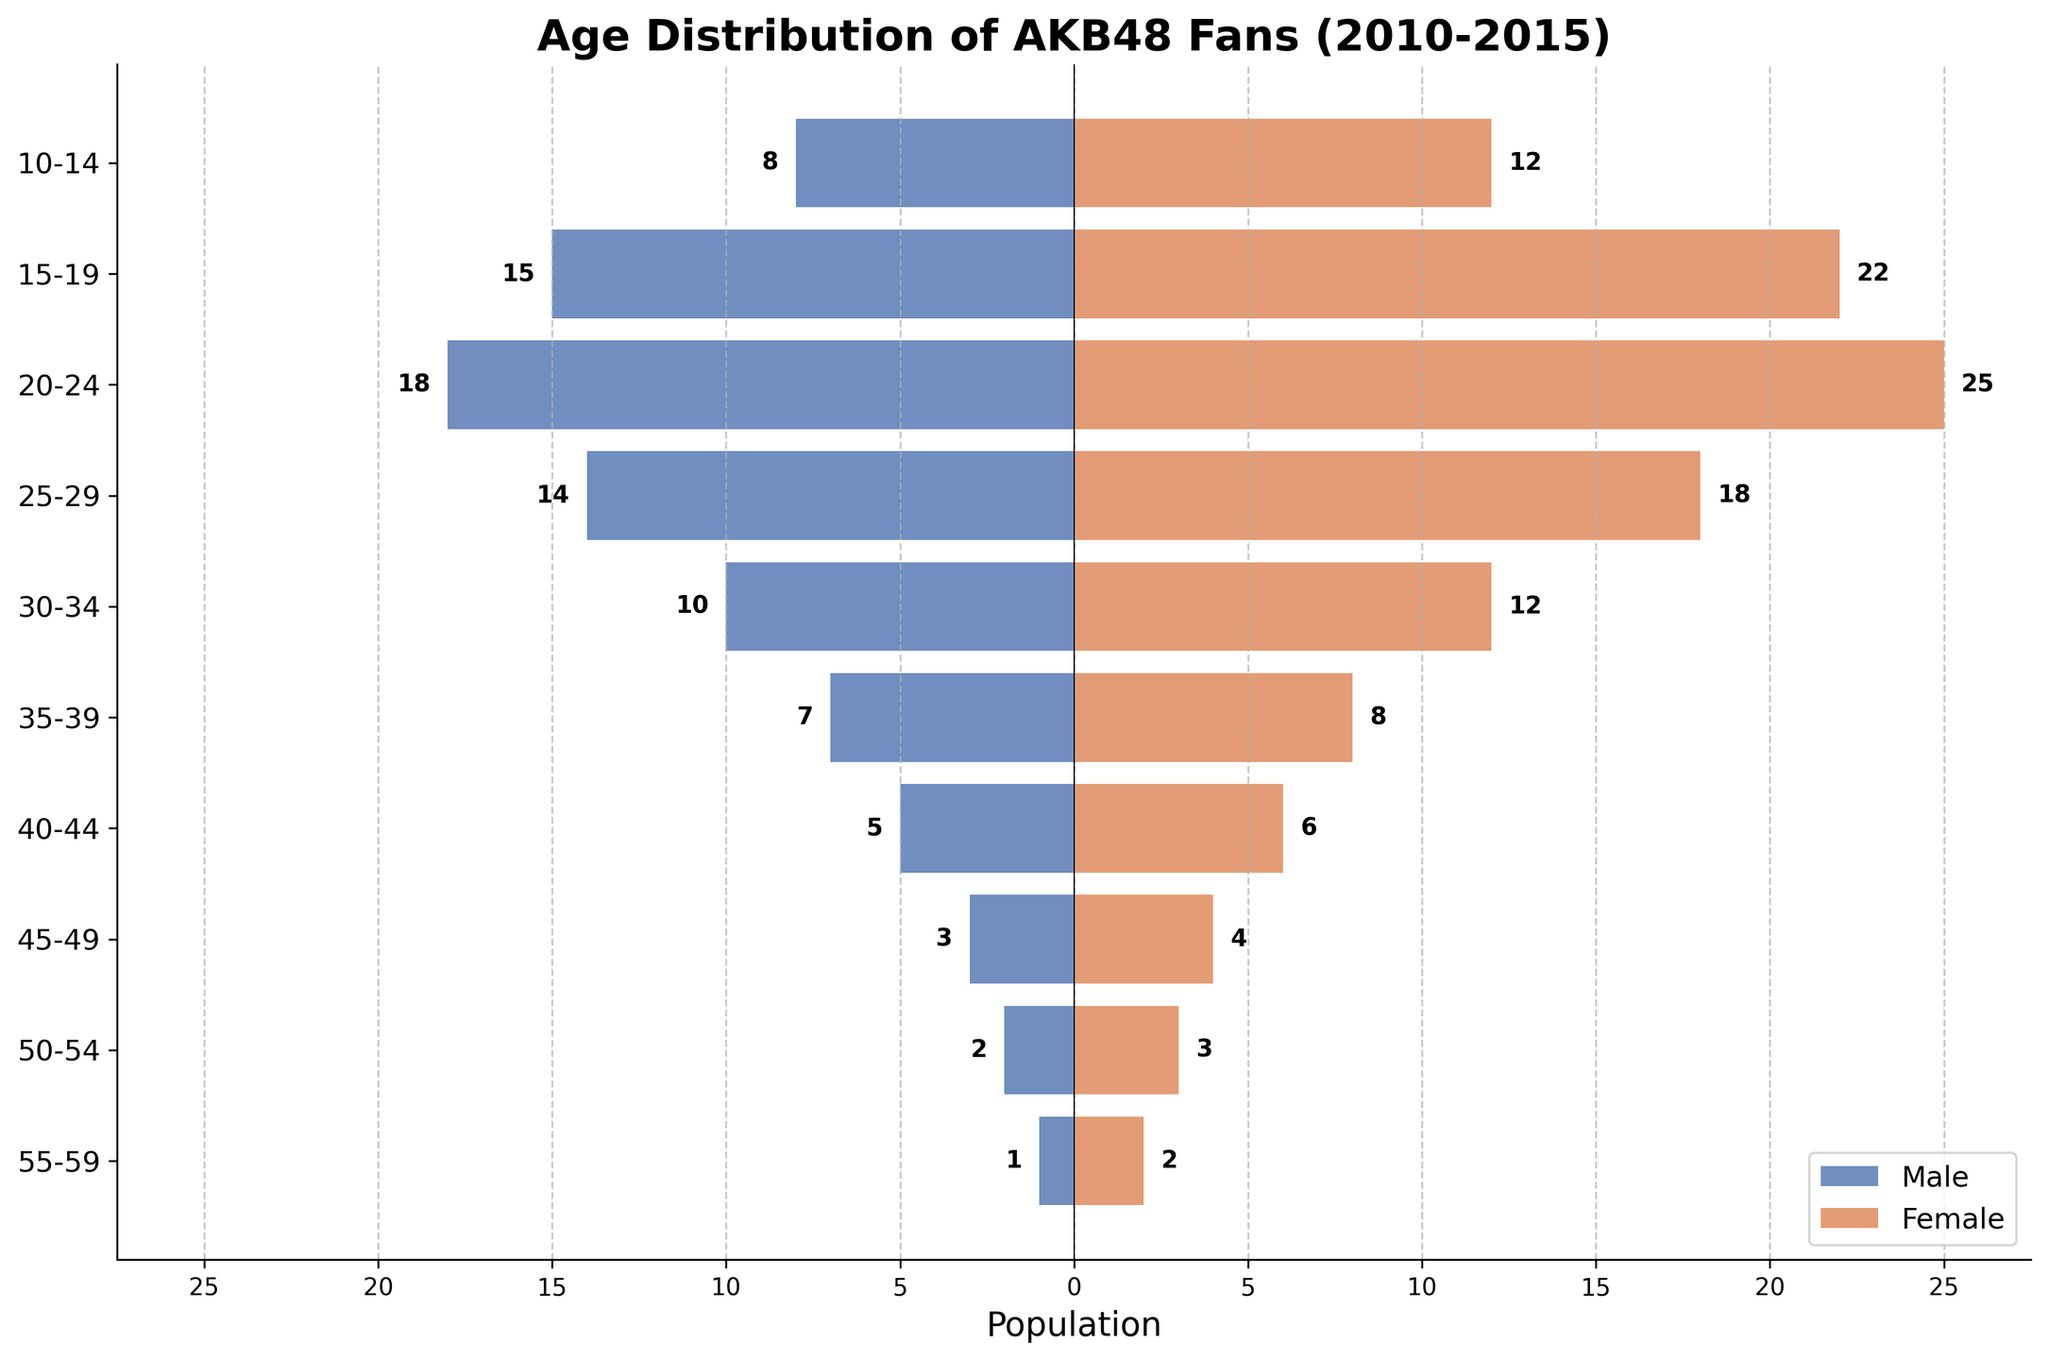How many age groups are there in the figure? Count all the unique age groups listed on the y-axis labels. There are 10 age groups: "10-14", "15-19", "20-24", "25-29", "30-34", "35-39", "40-44", "45-49", "50-54", and "55-59".
Answer: 10 What is the title of the figure? The title is displayed at the top of the figure. It reads "Age Distribution of AKB48 Fans (2010-2015)".
Answer: Age Distribution of AKB48 Fans (2010-2015) Which age group has the highest number of female fans? Look at the bar lengths for all age groups and focus on the female (right) side. The longest bar is for the "20-24" age group with 25 female fans.
Answer: 20-24 What is the total number of male fans? Sum the absolute values of all bars representing male fans: 8 + 15 + 18 + 14 + 10 + 7 + 5 + 3 + 2 + 1 = 83.
Answer: 83 What is the difference in the number of fans between males and females in the "15-19" age group? Look at the bar lengths for the "15-19" age group. There are 15 male fans and 22 female fans. The difference is 22 - 15 = 7.
Answer: 7 Which gender has more fans in the "35-39" age group? Compare the bar lengths for the "35-39" age group. There are 7 male fans and 8 female fans. Females have more fans.
Answer: Females What is the average number of female fans across all age groups? Sum the number of female fans across all age groups and divide by the number of age groups. (12 + 22 + 25 + 18 + 12 + 8 + 6 + 4 + 3 + 2) / 10 = 112 / 10 = 11.2
Answer: 11.2 Which age group has the lowest total number of fans (males + females)? Calculate the total number of fans for each age group and find the smallest: (10-14: 8+12=20), (15-19: 15+22=37), (20-24: 18+25=43), (25-29: 14+18=32), (30-34: 10+12=22), (35-39: 7+8=15), (40-44: 5+6=11), (45-49: 3+4=7), (50-54: 2+3=5), (55-59: 1+2=3). The "55-59" age group has the lowest total number of fans: 3.
Answer: 55-59 How many more female fans are there than male fans in the "20-24" age group? Look at the bar lengths for the "20-24" age group. There are 18 male fans and 25 female fans. The difference is 25 - 18 = 7.
Answer: 7 